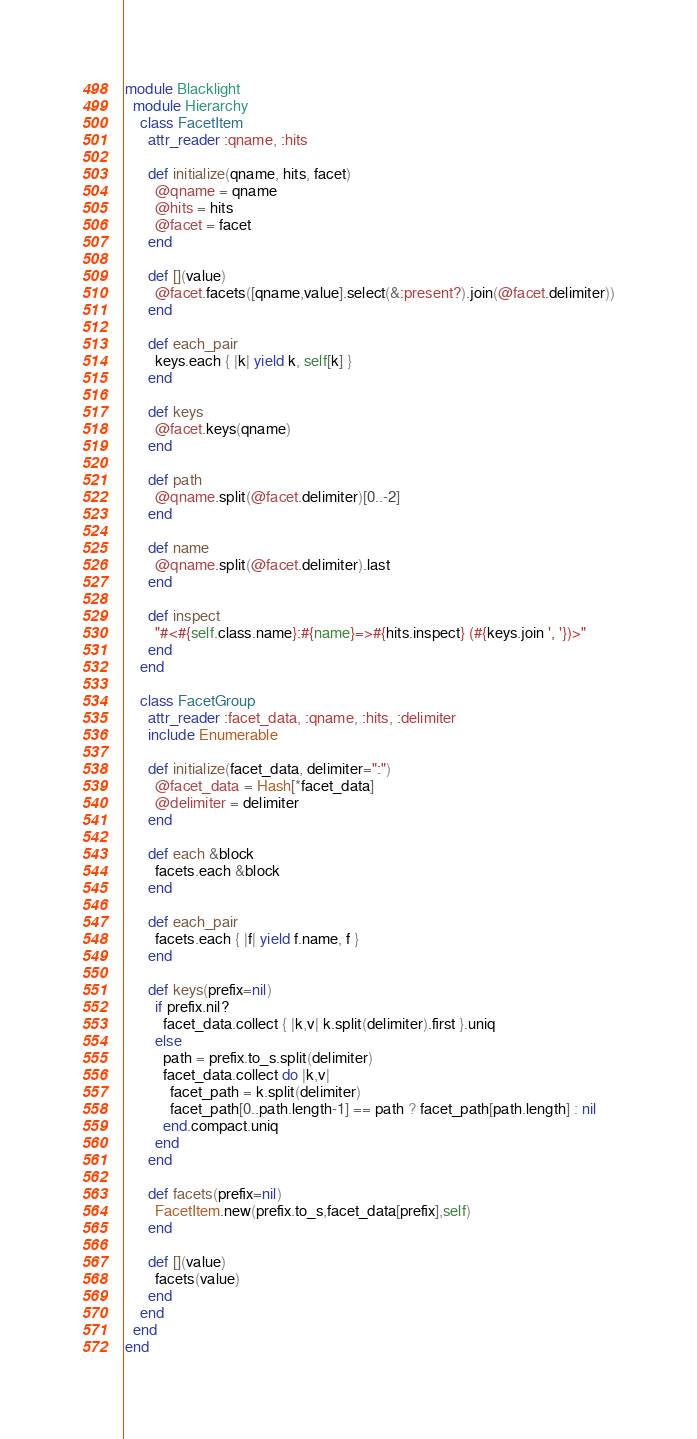<code> <loc_0><loc_0><loc_500><loc_500><_Ruby_>module Blacklight
  module Hierarchy
    class FacetItem
      attr_reader :qname, :hits
  
      def initialize(qname, hits, facet)
        @qname = qname
        @hits = hits
        @facet = facet
      end
  
      def [](value)
        @facet.facets([qname,value].select(&:present?).join(@facet.delimiter))
      end

      def each_pair
        keys.each { |k| yield k, self[k] }
      end
  
      def keys
        @facet.keys(qname)
      end

      def path
        @qname.split(@facet.delimiter)[0..-2]
      end
  
      def name
        @qname.split(@facet.delimiter).last
      end
  
      def inspect
        "#<#{self.class.name}:#{name}=>#{hits.inspect} (#{keys.join ', '})>"
      end
    end

    class FacetGroup
      attr_reader :facet_data, :qname, :hits, :delimiter
      include Enumerable
  
      def initialize(facet_data, delimiter=":")
        @facet_data = Hash[*facet_data]
        @delimiter = delimiter
      end
  
      def each &block
        facets.each &block
      end
  
      def each_pair
        facets.each { |f| yield f.name, f }
      end
  
      def keys(prefix=nil)
        if prefix.nil?
          facet_data.collect { |k,v| k.split(delimiter).first }.uniq
        else
          path = prefix.to_s.split(delimiter)
          facet_data.collect do |k,v|
            facet_path = k.split(delimiter)
            facet_path[0..path.length-1] == path ? facet_path[path.length] : nil
          end.compact.uniq
        end
      end
  
      def facets(prefix=nil)
        FacetItem.new(prefix.to_s,facet_data[prefix],self)
      end
  
      def [](value)
        facets(value)
      end
    end
  end
end
</code> 